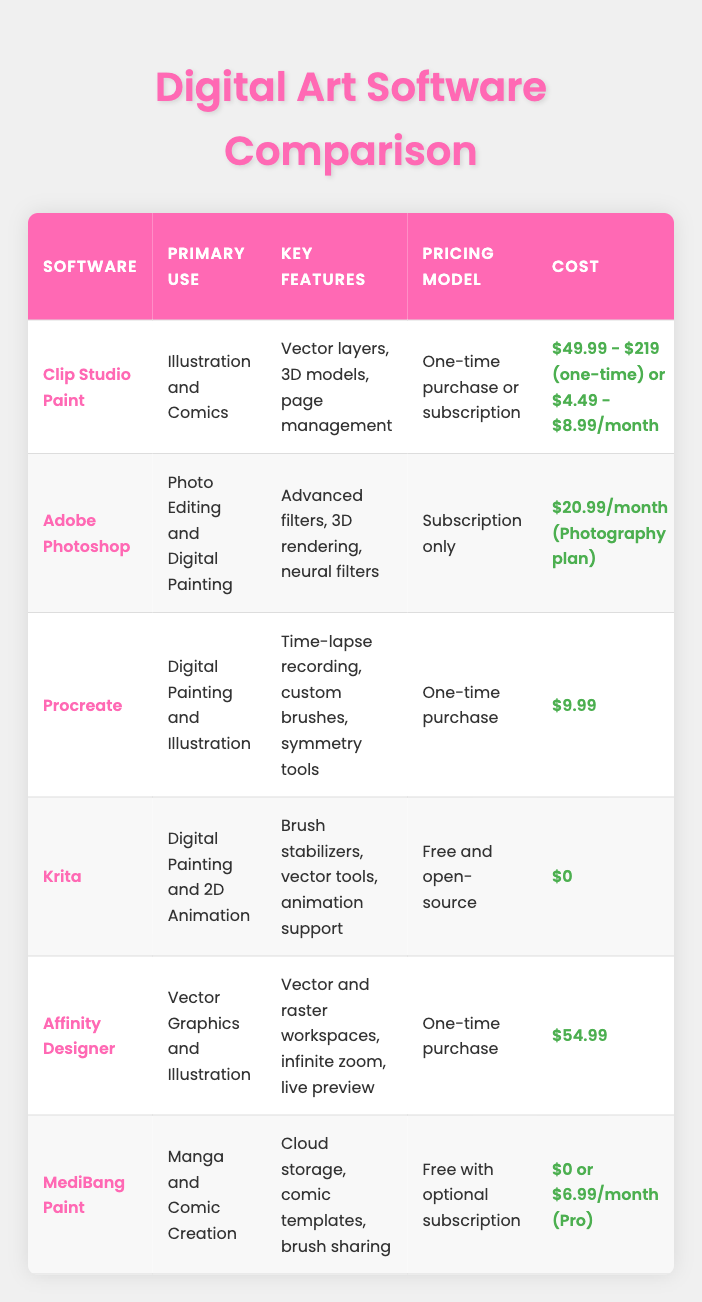What is the primary use of Affinity Designer? By looking at the table, we find the row for Affinity Designer, which indicates its primary use as "Vector Graphics and Illustration." This answers the question directly.
Answer: Vector Graphics and Illustration Which software has the lowest one-time purchase cost? In the cost column, we can observe that Procreate is listed at $9.99, which is lower than the others that have one-time purchase options. Thus, it has the lowest cost among them.
Answer: $9.99 Is Krita beginner-friendly? Referring to the beginner-friendly column for Krita, it states "Moderate." Therefore, this confirms that Krita is not strictly beginner-friendly, as it’s marked as moderate.
Answer: No How many software options support vector layers? We can see in the key features column that Clip Studio Paint and Krita both mention vector layers. Counting these gives us two options.
Answer: 2 What is the average cost for software with a subscription model? The subscription costs for Adobe Photoshop ($20.99/month) and MediBang Paint Pro ($6.99/month) can be averaged. The sum is 20.99 + 6.99 = 27.98, and there are 2 subscription models, so the average cost is 27.98/2 = 13.99.
Answer: $13.99 Which software has intermediate layer management? By checking the layer management column, we can see that Procreate and MediBang Paint both have "Intermediate" listed, therefore these are the two software options with this feature.
Answer: Procreate and MediBang Paint How many software options are available on iPad? Looking at the platform compatibility column, only Procreate, Adobe Photoshop, and Affinity Designer mention "iPad," resulting in three software options available on that platform.
Answer: 3 Is Clip Studio Paint's pricing model only a subscription? The table shows that Clip Studio Paint offers both a one-time purchase and a subscription. Thus, the answer is clearly no.
Answer: No What features do both Adobe Photoshop and Krita have in common? A close examination of the key features columns for both Adobe Photoshop and Krita reveals that both have extensive brush customization, allowing artists to make unique brushes. Thus, this is a common feature.
Answer: Extensive Brush Customization 